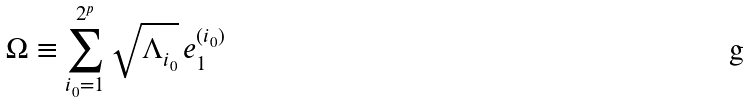Convert formula to latex. <formula><loc_0><loc_0><loc_500><loc_500>\Omega \equiv \sum _ { { i _ { 0 } } = 1 } ^ { 2 ^ { p } } \sqrt { \Lambda _ { i _ { 0 } } } \, e ^ { ( { i _ { 0 } } ) } _ { 1 }</formula> 